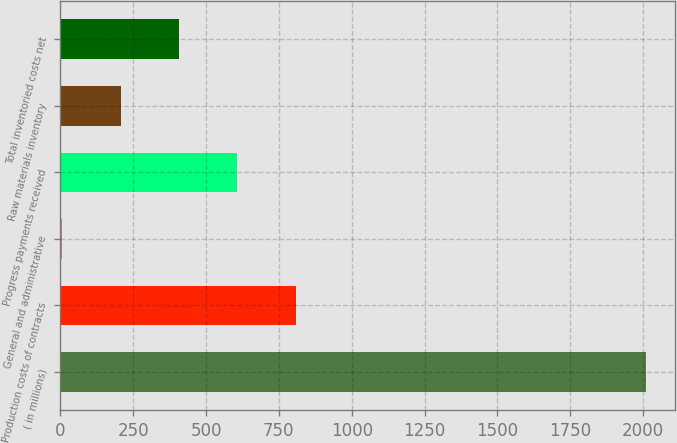Convert chart to OTSL. <chart><loc_0><loc_0><loc_500><loc_500><bar_chart><fcel>( in millions)<fcel>Production costs of contracts<fcel>General and administrative<fcel>Progress payments received<fcel>Raw materials inventory<fcel>Total inventoried costs net<nl><fcel>2010<fcel>808.2<fcel>7<fcel>607.9<fcel>207.3<fcel>407.6<nl></chart> 